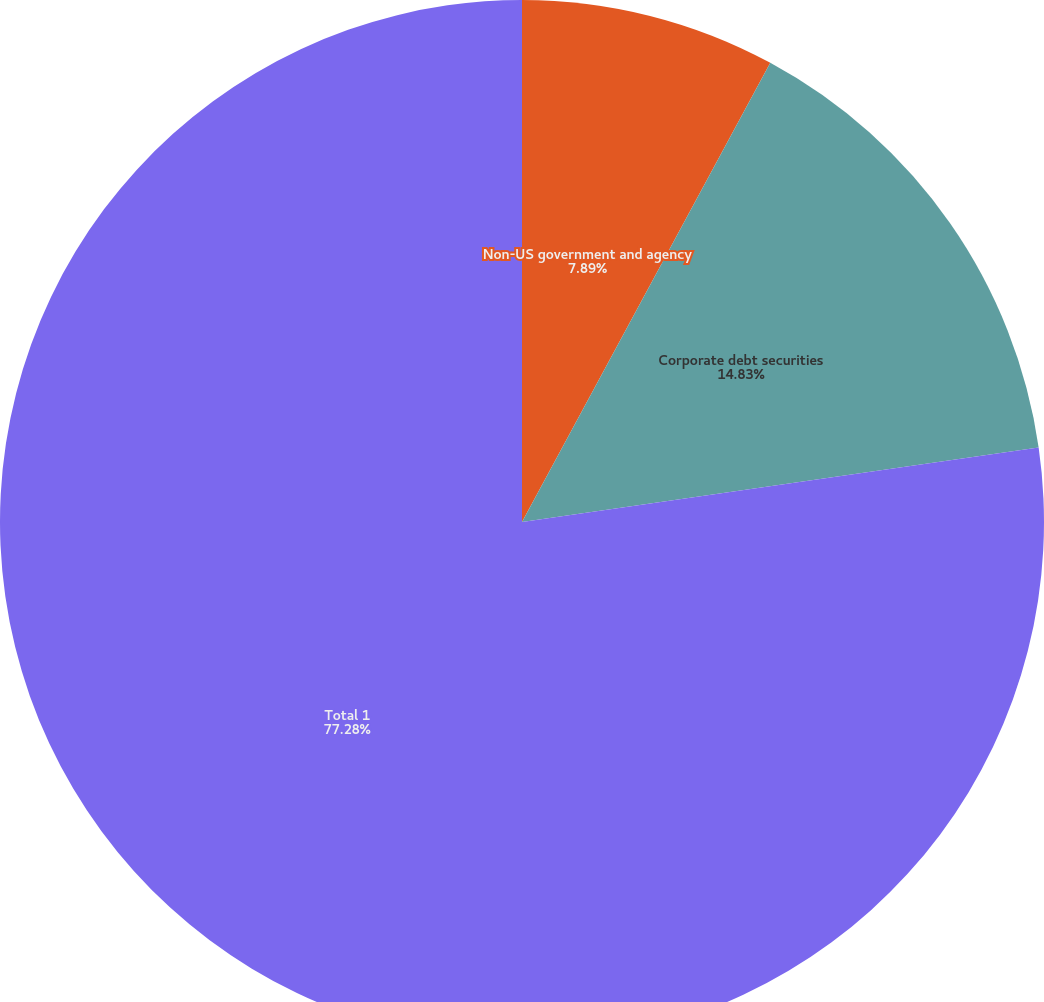Convert chart. <chart><loc_0><loc_0><loc_500><loc_500><pie_chart><fcel>Non-US government and agency<fcel>Corporate debt securities<fcel>Total 1<nl><fcel>7.89%<fcel>14.83%<fcel>77.28%<nl></chart> 